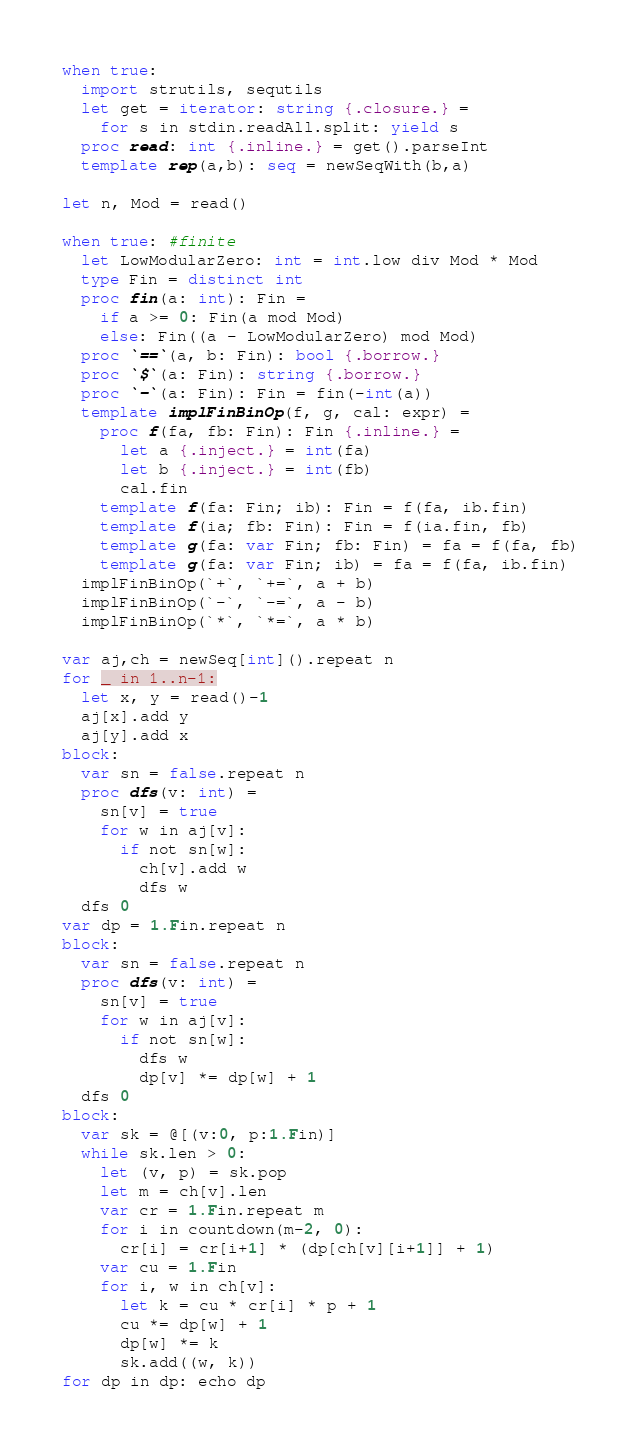<code> <loc_0><loc_0><loc_500><loc_500><_Nim_>when true:
  import strutils, sequtils
  let get = iterator: string {.closure.} =
    for s in stdin.readAll.split: yield s
  proc read: int {.inline.} = get().parseInt
  template rep(a,b): seq = newSeqWith(b,a)

let n, Mod = read()

when true: #finite
  let LowModularZero: int = int.low div Mod * Mod
  type Fin = distinct int
  proc fin(a: int): Fin = 
    if a >= 0: Fin(a mod Mod)
    else: Fin((a - LowModularZero) mod Mod)
  proc `==`(a, b: Fin): bool {.borrow.}
  proc `$`(a: Fin): string {.borrow.}
  proc `-`(a: Fin): Fin = fin(-int(a))  
  template implFinBinOp(f, g, cal: expr) =
    proc f(fa, fb: Fin): Fin {.inline.} =
      let a {.inject.} = int(fa)
      let b {.inject.} = int(fb)
      cal.fin
    template f(fa: Fin; ib): Fin = f(fa, ib.fin)
    template f(ia; fb: Fin): Fin = f(ia.fin, fb)
    template g(fa: var Fin; fb: Fin) = fa = f(fa, fb)
    template g(fa: var Fin; ib) = fa = f(fa, ib.fin)
  implFinBinOp(`+`, `+=`, a + b)
  implFinBinOp(`-`, `-=`, a - b)
  implFinBinOp(`*`, `*=`, a * b)

var aj,ch = newSeq[int]().repeat n
for _ in 1..n-1:
  let x, y = read()-1
  aj[x].add y
  aj[y].add x
block:
  var sn = false.repeat n
  proc dfs(v: int) =
    sn[v] = true
    for w in aj[v]:
      if not sn[w]:
        ch[v].add w
        dfs w
  dfs 0
var dp = 1.Fin.repeat n
block:
  var sn = false.repeat n
  proc dfs(v: int) =
    sn[v] = true
    for w in aj[v]:
      if not sn[w]:
        dfs w
        dp[v] *= dp[w] + 1
  dfs 0
block:
  var sk = @[(v:0, p:1.Fin)]
  while sk.len > 0:
    let (v, p) = sk.pop
    let m = ch[v].len
    var cr = 1.Fin.repeat m
    for i in countdown(m-2, 0):
      cr[i] = cr[i+1] * (dp[ch[v][i+1]] + 1)
    var cu = 1.Fin
    for i, w in ch[v]:
      let k = cu * cr[i] * p + 1
      cu *= dp[w] + 1
      dp[w] *= k
      sk.add((w, k))
for dp in dp: echo dp</code> 